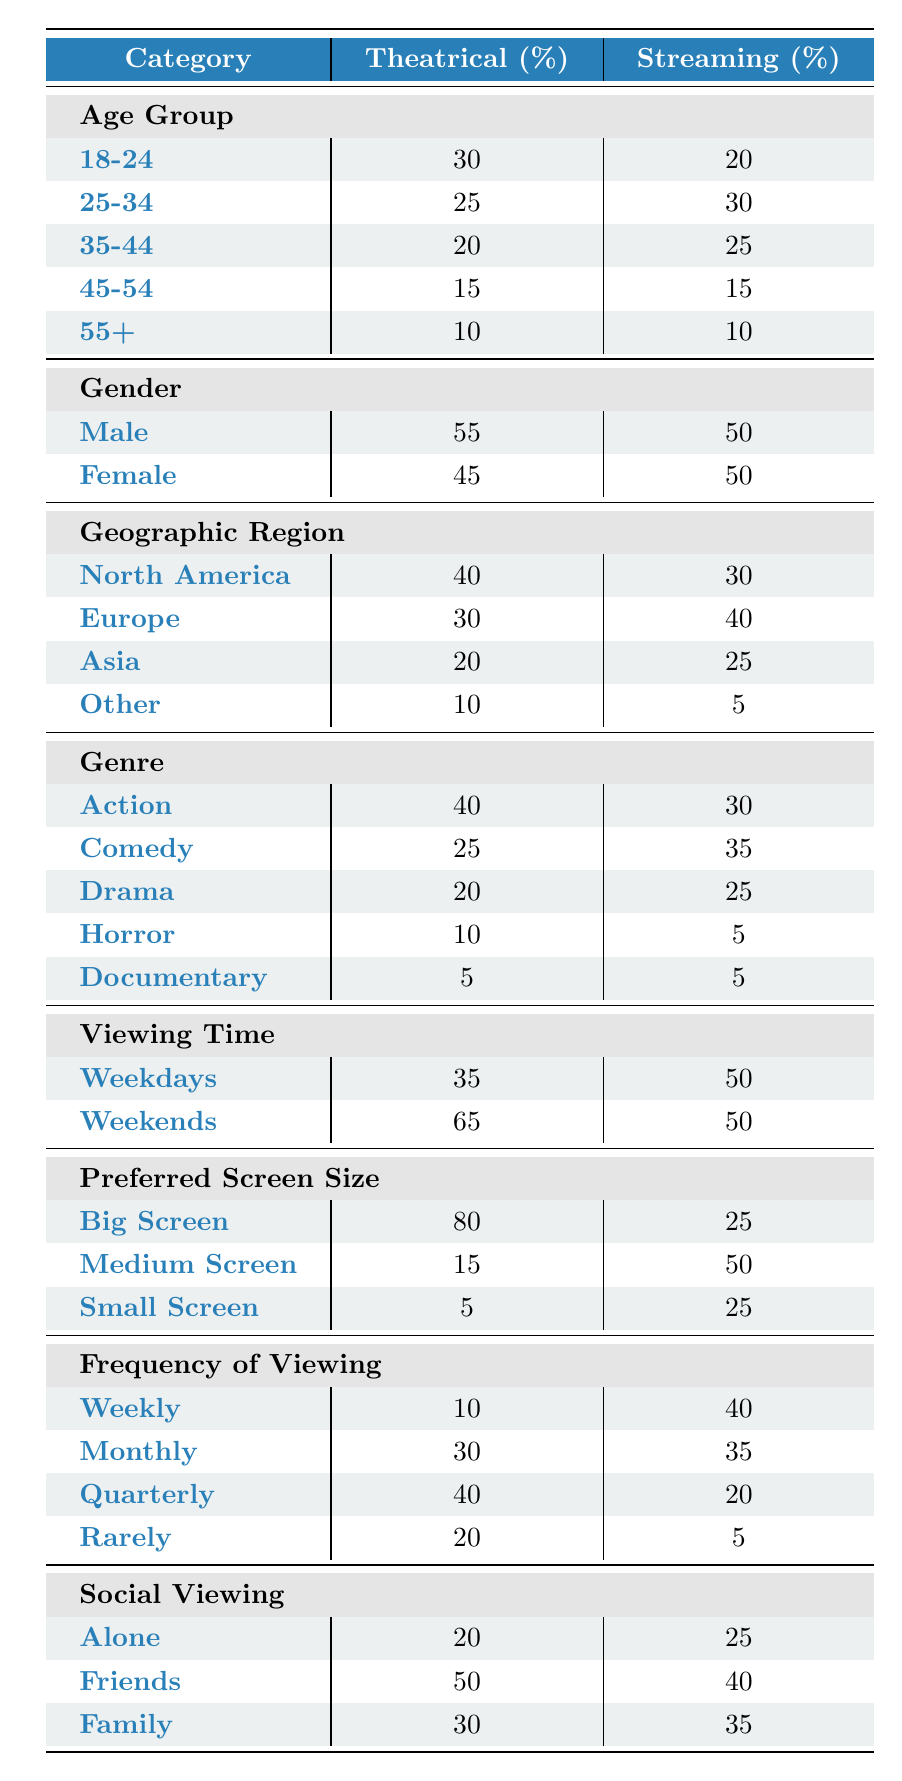What percentage of the theatrical audience is aged 25-34? From the Age Group section under Theatrical, 25-34 comprises 25% of the audience.
Answer: 25% Which format in theatrical viewing has the highest preference among audiences? In the Genre section, Action has the highest percentage of 40% in Theatrical viewing.
Answer: Action What is the combined percentage of theatrical viewers aged 45 and above? To find this, add the percentages of the age groups 45-54 (15%) and 55+ (10%): 15 + 10 = 25%.
Answer: 25% Is the percentage of males in the streaming audience greater than that in the theatrical audience? In the Gender section, the percentage of males in Theatrical is 55%, while in Streaming it is 50%. Therefore, the percentage of males in the streaming audience is not greater.
Answer: No What is the difference in the percentage of viewers who prefer Big Screen for theatrical versus streaming? The preference for Big Screen in Theatrical is 80% and in Streaming is 25%. The difference is calculated as 80 - 25 = 55%.
Answer: 55% What percentage of streaming viewers prefer to watch content alone? In the Social Viewing section, 25% of Streaming viewers prefer to watch alone.
Answer: 25% Are there more people who watch movies on weekends in streaming compared to theatrical? In the Viewing Time section, 65% of theatrical viewers watch on weekends, while in Streaming it is 50%. Since 65% is greater than 50%, more theatrical viewers watch on weekends.
Answer: No What is the average percentage of family viewers in both theatrical and streaming formats? The percentage for Family viewing is 30% in Theatrical and 35% in Streaming. To find the average, add them up: 30 + 35 = 65, then divide by 2: 65 / 2 = 32.5%.
Answer: 32.5% Do more than half of the theatrical audience watch movies with friends? The percentage of theatrical viewers who watch with Friends is 50%. Since this is equal to half but not more, the answer is no.
Answer: No 